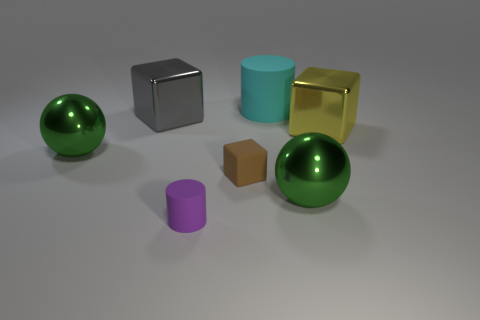Subtract all tiny brown rubber cubes. How many cubes are left? 2 Add 2 large green objects. How many objects exist? 9 Subtract all gray blocks. How many blocks are left? 2 Subtract all purple cubes. Subtract all yellow spheres. How many cubes are left? 3 Subtract 0 red cylinders. How many objects are left? 7 Subtract all blocks. How many objects are left? 4 Subtract all blue balls. Subtract all large gray metallic blocks. How many objects are left? 6 Add 3 big cubes. How many big cubes are left? 5 Add 3 purple blocks. How many purple blocks exist? 3 